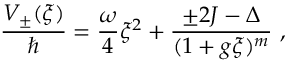<formula> <loc_0><loc_0><loc_500><loc_500>\frac { V _ { \pm } ( \xi ) } { } = \frac { \omega } { 4 } \xi ^ { 2 } + \frac { \pm 2 J - \Delta } { ( 1 + g \xi ) ^ { m } } \ ,</formula> 